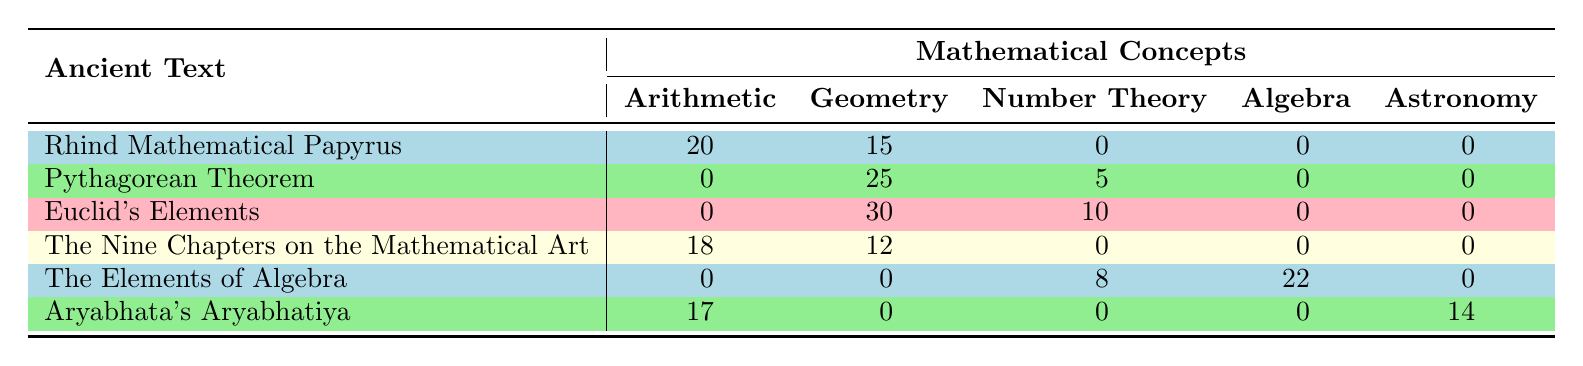What is the frequency of Arithmetic in Euclid's Elements? The table shows that Euclid's Elements has 0 frequency for Arithmetic. Therefore, the answer is directly taken from the corresponding cell.
Answer: 0 Which text has the highest frequency of Geometry? According to the table, Euclid's Elements has the highest frequency of Geometry with a value of 30. This is determined by comparing the frequencies across the texts listed under the Geometry column.
Answer: Euclid's Elements What is the total frequency of Number Theory across all texts? The combined total frequency for Number Theory is obtained by adding the values from the table: 5 (Pythagorean Theorem) + 10 (Euclid's Elements) + 8 (The Elements of Algebra) + 0 (Rhind Mathematical Papyrus) + 0 (The Nine Chapters on the Mathematical Art) + 0 (Aryabhata's Aryabhatiya) = 23.
Answer: 23 Does the Rhind Mathematical Papyrus include any concepts from Algebra? The table indicates that Rhind Mathematical Papyrus has a frequency of 0 for Algebra, confirming that it does not include this concept. Thus, the answer is straightforward.
Answer: No What is the average frequency of Arithmetic in the texts provided? The texts that include Arithmetic are: Rhind Mathematical Papyrus (20), The Nine Chapters on the Mathematical Art (18), Aryabhata's Aryabhatiya (17). The average is calculated as (20 + 18 + 17) / 3 = 55 / 3 = approximately 18.33.
Answer: 18.33 How many mathematical concepts are utilized in The Elements of Algebra? The table shows that The Elements of Algebra includes 2 concepts: Algebra (frequency 22) and Number Theory (frequency 8). Adding these gives a total of 2 concepts.
Answer: 2 Which text has a frequency of 14 in Astronomy? The table indicates that Aryabhata's Aryabhatiya corresponds to a frequency of 14 in Astronomy. This data is found directly in the relevant cell of the table.
Answer: Aryabhata's Aryabhatiya What is the difference in frequency between the highest and lowest Geometry values? The highest frequency of Geometry is from Euclid's Elements with a value of 30, and the lowest non-zero value is from The Nine Chapters on the Mathematical Art with a frequency of 12. The difference is calculated as 30 - 12 = 18.
Answer: 18 How many texts have no frequency of Geometric concepts? By examining the table, the texts that do not have any frequency listed for Geometry are: Rhind Mathematical Papyrus, The Elements of Algebra, and Aryabhata's Aryabhatiya. This gives a total of 3 texts.
Answer: 3 